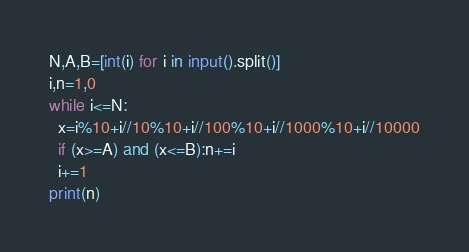Convert code to text. <code><loc_0><loc_0><loc_500><loc_500><_Python_>N,A,B=[int(i) for i in input().split()]
i,n=1,0
while i<=N:
  x=i%10+i//10%10+i//100%10+i//1000%10+i//10000
  if (x>=A) and (x<=B):n+=i
  i+=1
print(n)</code> 